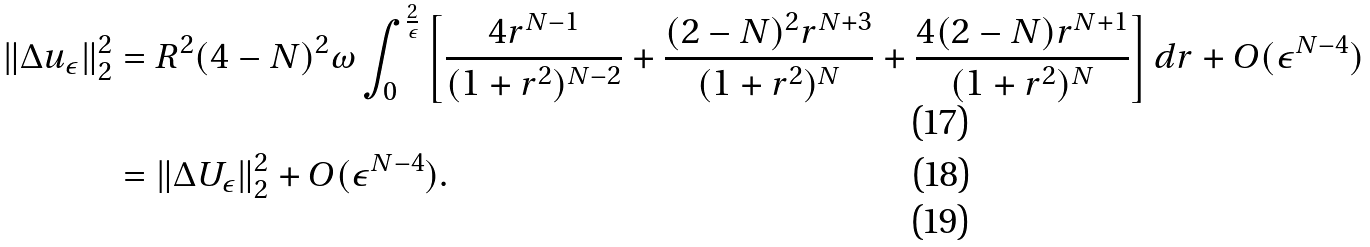Convert formula to latex. <formula><loc_0><loc_0><loc_500><loc_500>\| \Delta u _ { \epsilon } \| _ { 2 } ^ { 2 } & = R ^ { 2 } ( 4 - N ) ^ { 2 } \omega \int _ { 0 } ^ { \frac { 2 } { \epsilon } } \left [ \frac { 4 r ^ { N - 1 } } { ( 1 + r ^ { 2 } ) ^ { N - 2 } } + \frac { ( 2 - N ) ^ { 2 } r ^ { N + 3 } } { ( 1 + r ^ { 2 } ) ^ { N } } + \frac { 4 ( 2 - N ) r ^ { N + 1 } } { ( 1 + r ^ { 2 } ) ^ { N } } \right ] d r + O ( \epsilon ^ { N - 4 } ) \\ & = \| \Delta U _ { \epsilon } \| _ { 2 } ^ { 2 } + O ( \epsilon ^ { N - 4 } ) . \\</formula> 